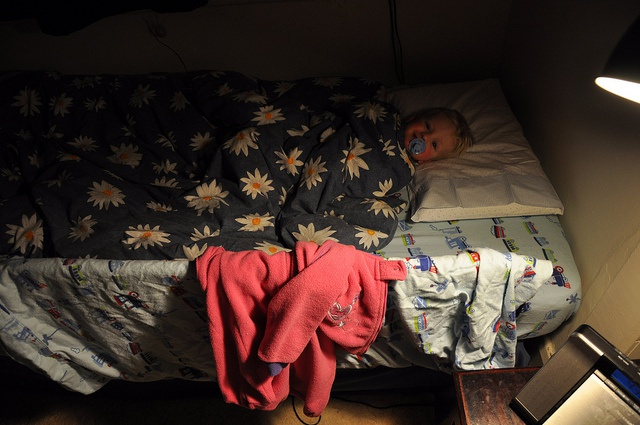Describe the objects in this image and their specific colors. I can see bed in black, gray, and darkgray tones and people in black and maroon tones in this image. 